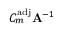<formula> <loc_0><loc_0><loc_500><loc_500>C _ { m } ^ { a d j } A ^ { - 1 }</formula> 